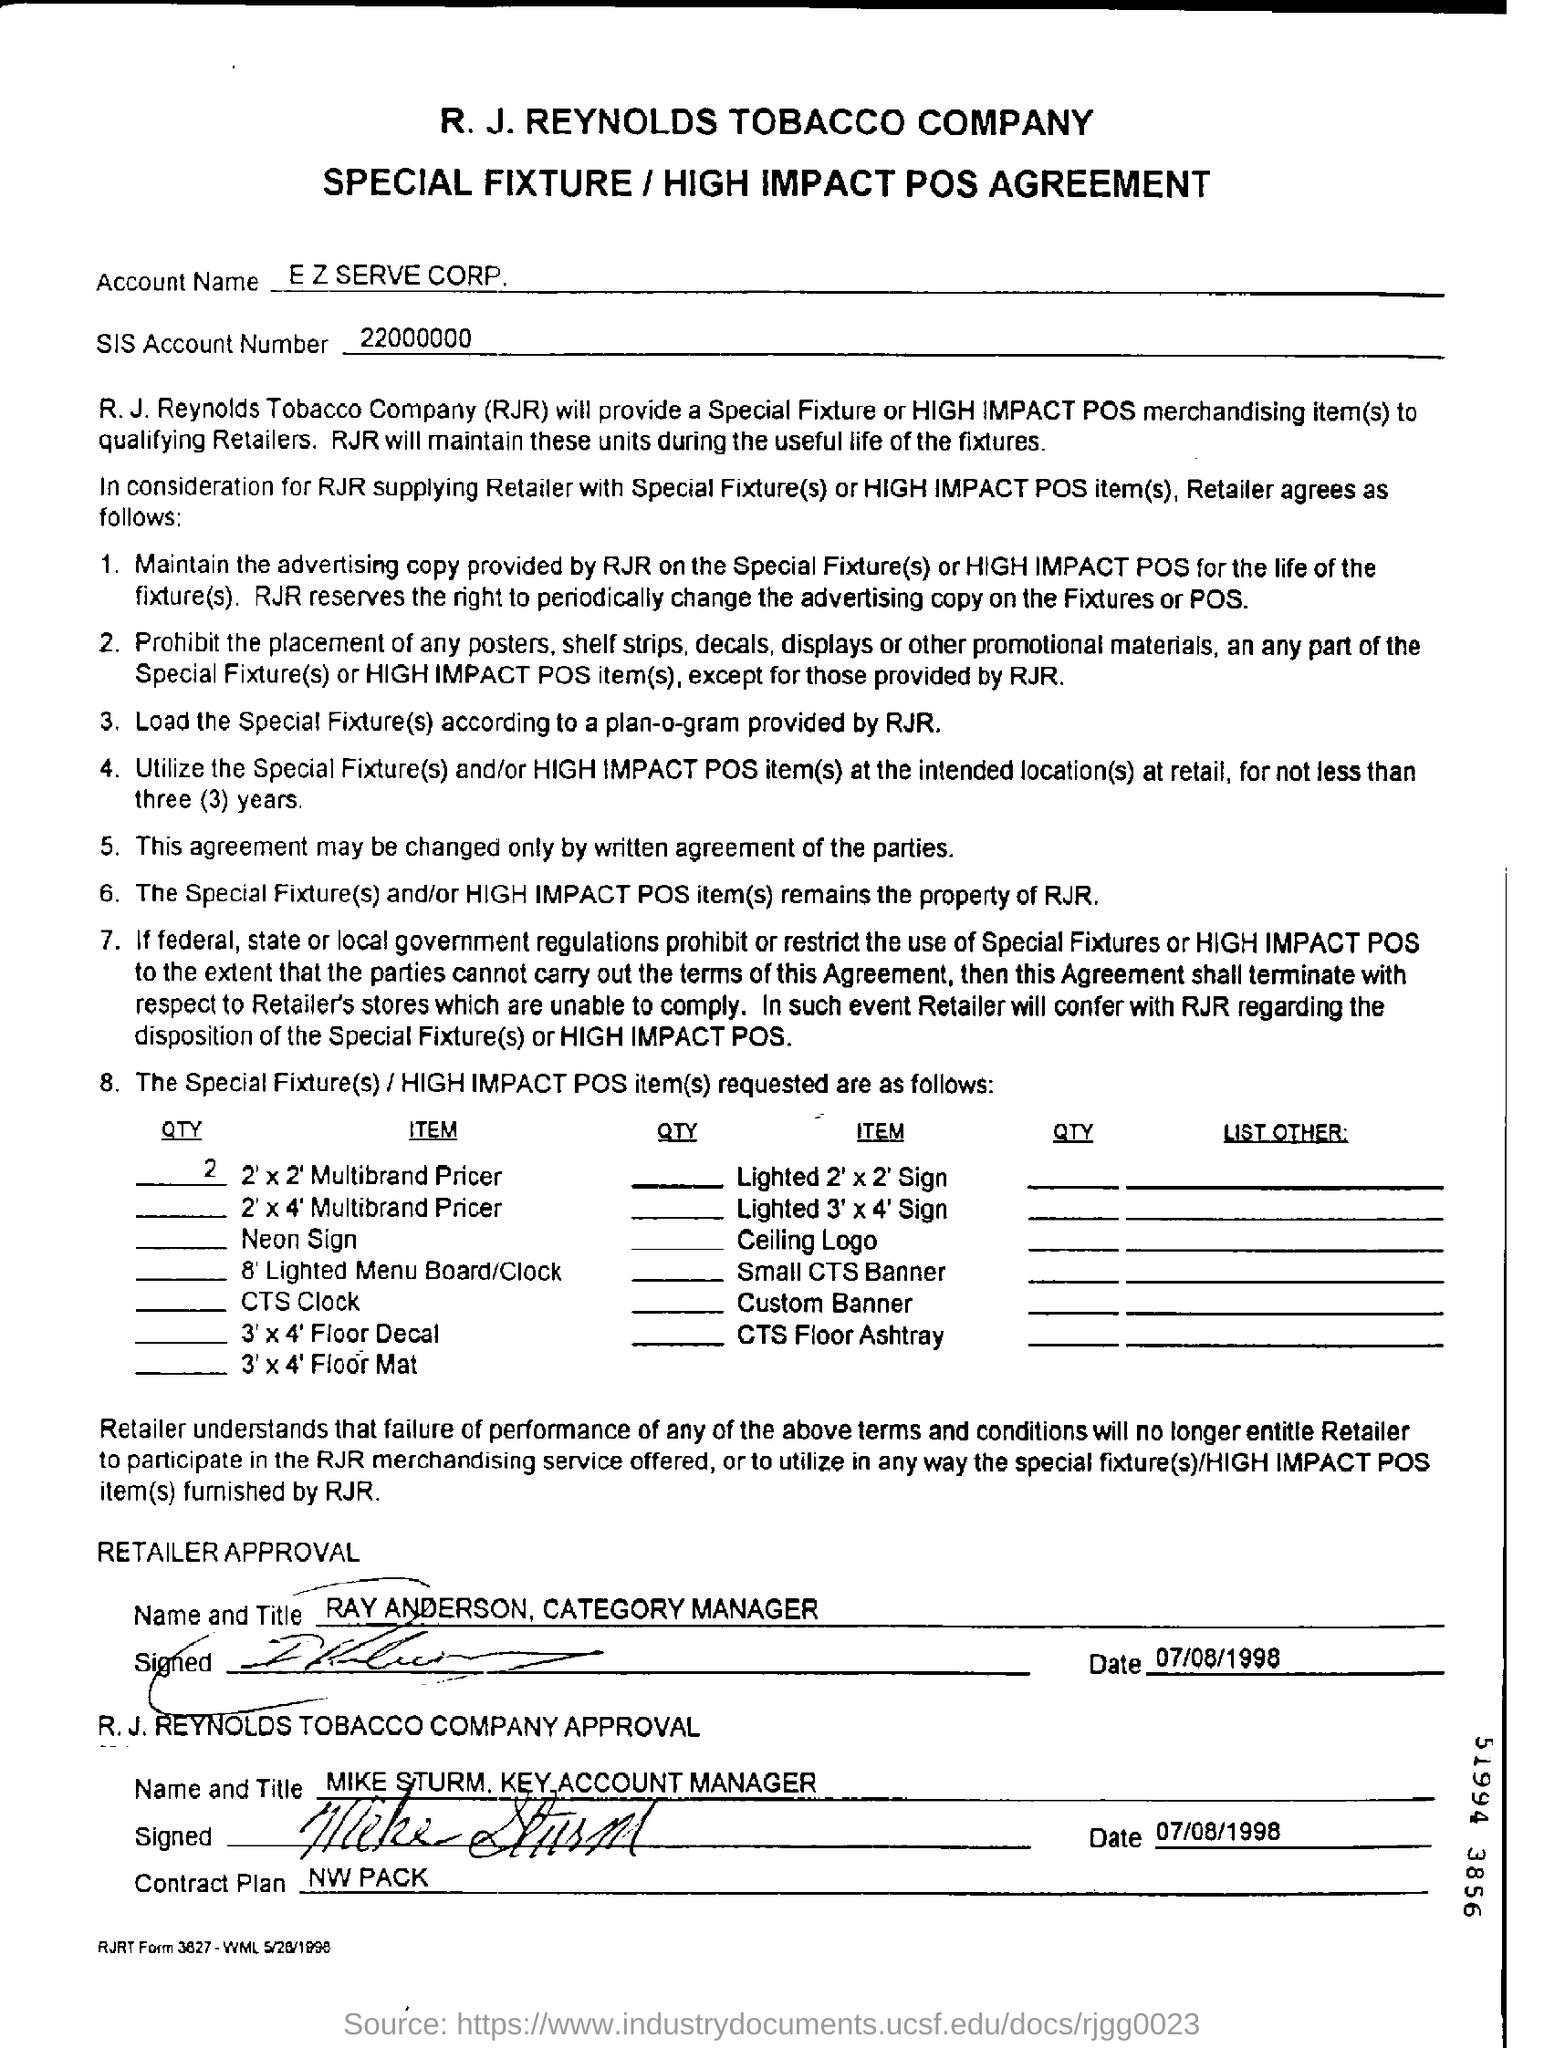What is the account name?
Provide a succinct answer. E Z serve corp. What is the sis account number?
Your answer should be very brief. 22000000. What is the date of retailer approval?
Offer a very short reply. 07/08/1998. 